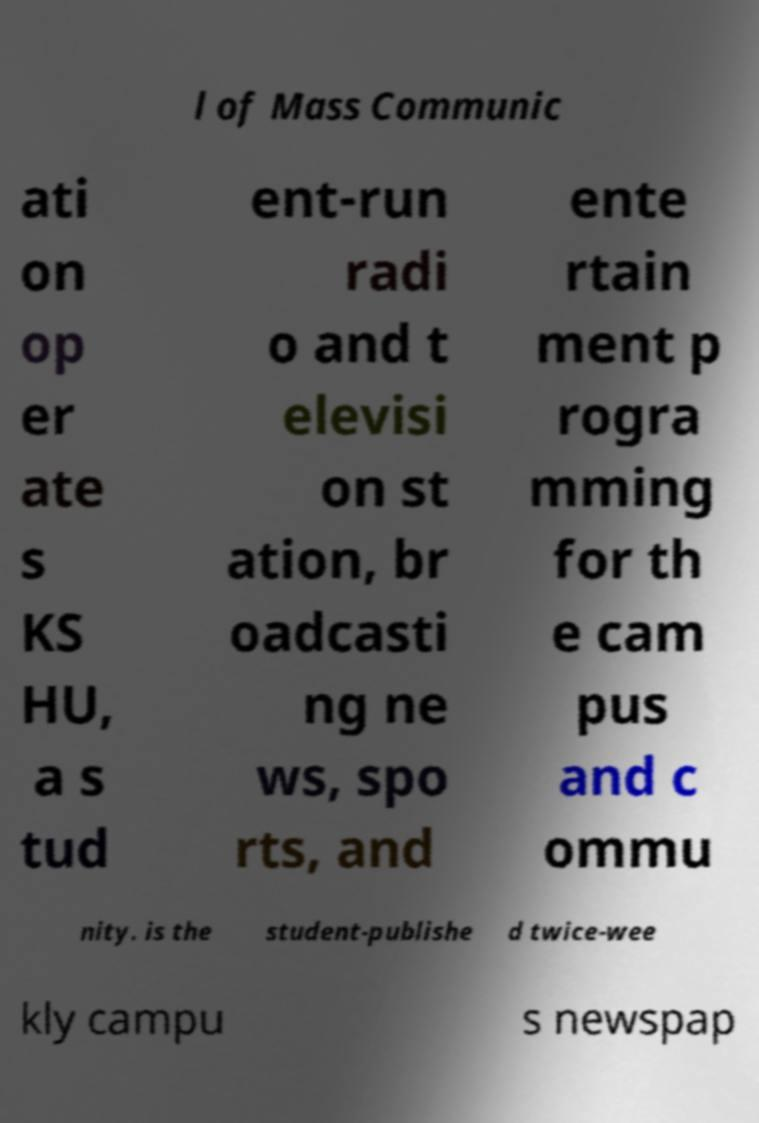There's text embedded in this image that I need extracted. Can you transcribe it verbatim? l of Mass Communic ati on op er ate s KS HU, a s tud ent-run radi o and t elevisi on st ation, br oadcasti ng ne ws, spo rts, and ente rtain ment p rogra mming for th e cam pus and c ommu nity. is the student-publishe d twice-wee kly campu s newspap 